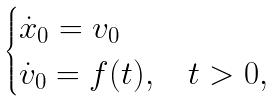Convert formula to latex. <formula><loc_0><loc_0><loc_500><loc_500>\begin{cases} \dot { x } _ { 0 } = v _ { 0 } \\ \dot { v } _ { 0 } = f ( t ) , \quad t > 0 , \end{cases}</formula> 